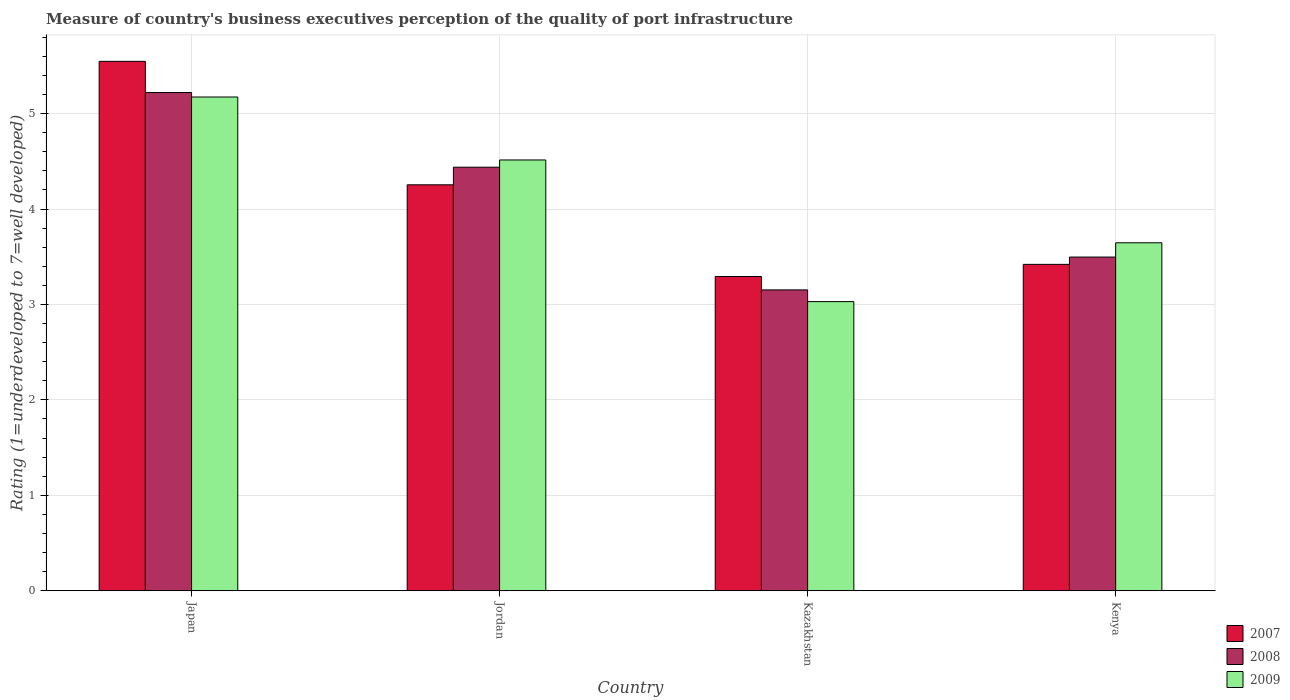How many different coloured bars are there?
Ensure brevity in your answer.  3. Are the number of bars per tick equal to the number of legend labels?
Offer a very short reply. Yes. Are the number of bars on each tick of the X-axis equal?
Your answer should be compact. Yes. How many bars are there on the 3rd tick from the left?
Your answer should be very brief. 3. What is the label of the 3rd group of bars from the left?
Offer a very short reply. Kazakhstan. In how many cases, is the number of bars for a given country not equal to the number of legend labels?
Your answer should be compact. 0. What is the ratings of the quality of port infrastructure in 2009 in Kazakhstan?
Your answer should be very brief. 3.03. Across all countries, what is the maximum ratings of the quality of port infrastructure in 2009?
Provide a succinct answer. 5.17. Across all countries, what is the minimum ratings of the quality of port infrastructure in 2008?
Give a very brief answer. 3.15. In which country was the ratings of the quality of port infrastructure in 2007 minimum?
Make the answer very short. Kazakhstan. What is the total ratings of the quality of port infrastructure in 2009 in the graph?
Offer a terse response. 16.36. What is the difference between the ratings of the quality of port infrastructure in 2007 in Japan and that in Kenya?
Your answer should be compact. 2.13. What is the difference between the ratings of the quality of port infrastructure in 2008 in Kazakhstan and the ratings of the quality of port infrastructure in 2009 in Kenya?
Make the answer very short. -0.49. What is the average ratings of the quality of port infrastructure in 2009 per country?
Your response must be concise. 4.09. What is the difference between the ratings of the quality of port infrastructure of/in 2008 and ratings of the quality of port infrastructure of/in 2009 in Kenya?
Make the answer very short. -0.15. What is the ratio of the ratings of the quality of port infrastructure in 2008 in Jordan to that in Kenya?
Your answer should be very brief. 1.27. Is the ratings of the quality of port infrastructure in 2009 in Japan less than that in Kazakhstan?
Your answer should be very brief. No. What is the difference between the highest and the second highest ratings of the quality of port infrastructure in 2007?
Your response must be concise. -0.83. What is the difference between the highest and the lowest ratings of the quality of port infrastructure in 2009?
Your answer should be very brief. 2.14. In how many countries, is the ratings of the quality of port infrastructure in 2008 greater than the average ratings of the quality of port infrastructure in 2008 taken over all countries?
Offer a very short reply. 2. What does the 1st bar from the left in Japan represents?
Make the answer very short. 2007. What does the 1st bar from the right in Kazakhstan represents?
Ensure brevity in your answer.  2009. Is it the case that in every country, the sum of the ratings of the quality of port infrastructure in 2007 and ratings of the quality of port infrastructure in 2008 is greater than the ratings of the quality of port infrastructure in 2009?
Give a very brief answer. Yes. How many countries are there in the graph?
Your answer should be very brief. 4. What is the difference between two consecutive major ticks on the Y-axis?
Your answer should be compact. 1. Does the graph contain any zero values?
Your response must be concise. No. Where does the legend appear in the graph?
Offer a terse response. Bottom right. How are the legend labels stacked?
Ensure brevity in your answer.  Vertical. What is the title of the graph?
Provide a succinct answer. Measure of country's business executives perception of the quality of port infrastructure. What is the label or title of the X-axis?
Provide a short and direct response. Country. What is the label or title of the Y-axis?
Provide a succinct answer. Rating (1=underdeveloped to 7=well developed). What is the Rating (1=underdeveloped to 7=well developed) of 2007 in Japan?
Offer a very short reply. 5.55. What is the Rating (1=underdeveloped to 7=well developed) of 2008 in Japan?
Your answer should be very brief. 5.22. What is the Rating (1=underdeveloped to 7=well developed) in 2009 in Japan?
Your answer should be very brief. 5.17. What is the Rating (1=underdeveloped to 7=well developed) of 2007 in Jordan?
Give a very brief answer. 4.25. What is the Rating (1=underdeveloped to 7=well developed) in 2008 in Jordan?
Your response must be concise. 4.44. What is the Rating (1=underdeveloped to 7=well developed) in 2009 in Jordan?
Give a very brief answer. 4.51. What is the Rating (1=underdeveloped to 7=well developed) of 2007 in Kazakhstan?
Offer a very short reply. 3.29. What is the Rating (1=underdeveloped to 7=well developed) of 2008 in Kazakhstan?
Your answer should be compact. 3.15. What is the Rating (1=underdeveloped to 7=well developed) in 2009 in Kazakhstan?
Provide a short and direct response. 3.03. What is the Rating (1=underdeveloped to 7=well developed) in 2007 in Kenya?
Your answer should be very brief. 3.42. What is the Rating (1=underdeveloped to 7=well developed) in 2008 in Kenya?
Your answer should be compact. 3.5. What is the Rating (1=underdeveloped to 7=well developed) in 2009 in Kenya?
Give a very brief answer. 3.65. Across all countries, what is the maximum Rating (1=underdeveloped to 7=well developed) in 2007?
Your response must be concise. 5.55. Across all countries, what is the maximum Rating (1=underdeveloped to 7=well developed) of 2008?
Make the answer very short. 5.22. Across all countries, what is the maximum Rating (1=underdeveloped to 7=well developed) in 2009?
Keep it short and to the point. 5.17. Across all countries, what is the minimum Rating (1=underdeveloped to 7=well developed) in 2007?
Offer a very short reply. 3.29. Across all countries, what is the minimum Rating (1=underdeveloped to 7=well developed) of 2008?
Your response must be concise. 3.15. Across all countries, what is the minimum Rating (1=underdeveloped to 7=well developed) in 2009?
Give a very brief answer. 3.03. What is the total Rating (1=underdeveloped to 7=well developed) in 2007 in the graph?
Make the answer very short. 16.51. What is the total Rating (1=underdeveloped to 7=well developed) of 2008 in the graph?
Give a very brief answer. 16.31. What is the total Rating (1=underdeveloped to 7=well developed) of 2009 in the graph?
Ensure brevity in your answer.  16.36. What is the difference between the Rating (1=underdeveloped to 7=well developed) in 2007 in Japan and that in Jordan?
Offer a very short reply. 1.29. What is the difference between the Rating (1=underdeveloped to 7=well developed) of 2008 in Japan and that in Jordan?
Provide a short and direct response. 0.78. What is the difference between the Rating (1=underdeveloped to 7=well developed) of 2009 in Japan and that in Jordan?
Make the answer very short. 0.66. What is the difference between the Rating (1=underdeveloped to 7=well developed) in 2007 in Japan and that in Kazakhstan?
Provide a short and direct response. 2.25. What is the difference between the Rating (1=underdeveloped to 7=well developed) of 2008 in Japan and that in Kazakhstan?
Provide a succinct answer. 2.07. What is the difference between the Rating (1=underdeveloped to 7=well developed) in 2009 in Japan and that in Kazakhstan?
Your answer should be compact. 2.14. What is the difference between the Rating (1=underdeveloped to 7=well developed) in 2007 in Japan and that in Kenya?
Your answer should be very brief. 2.13. What is the difference between the Rating (1=underdeveloped to 7=well developed) in 2008 in Japan and that in Kenya?
Your answer should be very brief. 1.72. What is the difference between the Rating (1=underdeveloped to 7=well developed) of 2009 in Japan and that in Kenya?
Your response must be concise. 1.53. What is the difference between the Rating (1=underdeveloped to 7=well developed) in 2007 in Jordan and that in Kazakhstan?
Make the answer very short. 0.96. What is the difference between the Rating (1=underdeveloped to 7=well developed) of 2008 in Jordan and that in Kazakhstan?
Your answer should be very brief. 1.29. What is the difference between the Rating (1=underdeveloped to 7=well developed) of 2009 in Jordan and that in Kazakhstan?
Your answer should be very brief. 1.48. What is the difference between the Rating (1=underdeveloped to 7=well developed) in 2007 in Jordan and that in Kenya?
Provide a succinct answer. 0.83. What is the difference between the Rating (1=underdeveloped to 7=well developed) of 2008 in Jordan and that in Kenya?
Offer a very short reply. 0.94. What is the difference between the Rating (1=underdeveloped to 7=well developed) in 2009 in Jordan and that in Kenya?
Provide a short and direct response. 0.87. What is the difference between the Rating (1=underdeveloped to 7=well developed) of 2007 in Kazakhstan and that in Kenya?
Your answer should be very brief. -0.13. What is the difference between the Rating (1=underdeveloped to 7=well developed) of 2008 in Kazakhstan and that in Kenya?
Your answer should be very brief. -0.34. What is the difference between the Rating (1=underdeveloped to 7=well developed) of 2009 in Kazakhstan and that in Kenya?
Offer a terse response. -0.62. What is the difference between the Rating (1=underdeveloped to 7=well developed) of 2007 in Japan and the Rating (1=underdeveloped to 7=well developed) of 2008 in Jordan?
Your answer should be very brief. 1.11. What is the difference between the Rating (1=underdeveloped to 7=well developed) in 2007 in Japan and the Rating (1=underdeveloped to 7=well developed) in 2009 in Jordan?
Provide a succinct answer. 1.03. What is the difference between the Rating (1=underdeveloped to 7=well developed) in 2008 in Japan and the Rating (1=underdeveloped to 7=well developed) in 2009 in Jordan?
Ensure brevity in your answer.  0.71. What is the difference between the Rating (1=underdeveloped to 7=well developed) in 2007 in Japan and the Rating (1=underdeveloped to 7=well developed) in 2008 in Kazakhstan?
Your response must be concise. 2.4. What is the difference between the Rating (1=underdeveloped to 7=well developed) in 2007 in Japan and the Rating (1=underdeveloped to 7=well developed) in 2009 in Kazakhstan?
Offer a terse response. 2.52. What is the difference between the Rating (1=underdeveloped to 7=well developed) in 2008 in Japan and the Rating (1=underdeveloped to 7=well developed) in 2009 in Kazakhstan?
Provide a short and direct response. 2.19. What is the difference between the Rating (1=underdeveloped to 7=well developed) in 2007 in Japan and the Rating (1=underdeveloped to 7=well developed) in 2008 in Kenya?
Provide a short and direct response. 2.05. What is the difference between the Rating (1=underdeveloped to 7=well developed) in 2007 in Japan and the Rating (1=underdeveloped to 7=well developed) in 2009 in Kenya?
Offer a very short reply. 1.9. What is the difference between the Rating (1=underdeveloped to 7=well developed) in 2008 in Japan and the Rating (1=underdeveloped to 7=well developed) in 2009 in Kenya?
Offer a very short reply. 1.57. What is the difference between the Rating (1=underdeveloped to 7=well developed) in 2007 in Jordan and the Rating (1=underdeveloped to 7=well developed) in 2008 in Kazakhstan?
Your answer should be very brief. 1.1. What is the difference between the Rating (1=underdeveloped to 7=well developed) in 2007 in Jordan and the Rating (1=underdeveloped to 7=well developed) in 2009 in Kazakhstan?
Give a very brief answer. 1.22. What is the difference between the Rating (1=underdeveloped to 7=well developed) in 2008 in Jordan and the Rating (1=underdeveloped to 7=well developed) in 2009 in Kazakhstan?
Provide a succinct answer. 1.41. What is the difference between the Rating (1=underdeveloped to 7=well developed) in 2007 in Jordan and the Rating (1=underdeveloped to 7=well developed) in 2008 in Kenya?
Offer a very short reply. 0.76. What is the difference between the Rating (1=underdeveloped to 7=well developed) of 2007 in Jordan and the Rating (1=underdeveloped to 7=well developed) of 2009 in Kenya?
Ensure brevity in your answer.  0.61. What is the difference between the Rating (1=underdeveloped to 7=well developed) in 2008 in Jordan and the Rating (1=underdeveloped to 7=well developed) in 2009 in Kenya?
Your answer should be very brief. 0.79. What is the difference between the Rating (1=underdeveloped to 7=well developed) of 2007 in Kazakhstan and the Rating (1=underdeveloped to 7=well developed) of 2008 in Kenya?
Offer a very short reply. -0.2. What is the difference between the Rating (1=underdeveloped to 7=well developed) in 2007 in Kazakhstan and the Rating (1=underdeveloped to 7=well developed) in 2009 in Kenya?
Your answer should be compact. -0.35. What is the difference between the Rating (1=underdeveloped to 7=well developed) of 2008 in Kazakhstan and the Rating (1=underdeveloped to 7=well developed) of 2009 in Kenya?
Make the answer very short. -0.49. What is the average Rating (1=underdeveloped to 7=well developed) in 2007 per country?
Keep it short and to the point. 4.13. What is the average Rating (1=underdeveloped to 7=well developed) in 2008 per country?
Provide a succinct answer. 4.08. What is the average Rating (1=underdeveloped to 7=well developed) in 2009 per country?
Offer a very short reply. 4.09. What is the difference between the Rating (1=underdeveloped to 7=well developed) in 2007 and Rating (1=underdeveloped to 7=well developed) in 2008 in Japan?
Make the answer very short. 0.33. What is the difference between the Rating (1=underdeveloped to 7=well developed) of 2007 and Rating (1=underdeveloped to 7=well developed) of 2009 in Japan?
Offer a terse response. 0.37. What is the difference between the Rating (1=underdeveloped to 7=well developed) of 2008 and Rating (1=underdeveloped to 7=well developed) of 2009 in Japan?
Offer a very short reply. 0.05. What is the difference between the Rating (1=underdeveloped to 7=well developed) of 2007 and Rating (1=underdeveloped to 7=well developed) of 2008 in Jordan?
Keep it short and to the point. -0.18. What is the difference between the Rating (1=underdeveloped to 7=well developed) in 2007 and Rating (1=underdeveloped to 7=well developed) in 2009 in Jordan?
Provide a short and direct response. -0.26. What is the difference between the Rating (1=underdeveloped to 7=well developed) of 2008 and Rating (1=underdeveloped to 7=well developed) of 2009 in Jordan?
Your response must be concise. -0.08. What is the difference between the Rating (1=underdeveloped to 7=well developed) in 2007 and Rating (1=underdeveloped to 7=well developed) in 2008 in Kazakhstan?
Offer a terse response. 0.14. What is the difference between the Rating (1=underdeveloped to 7=well developed) in 2007 and Rating (1=underdeveloped to 7=well developed) in 2009 in Kazakhstan?
Provide a short and direct response. 0.26. What is the difference between the Rating (1=underdeveloped to 7=well developed) of 2008 and Rating (1=underdeveloped to 7=well developed) of 2009 in Kazakhstan?
Your answer should be very brief. 0.12. What is the difference between the Rating (1=underdeveloped to 7=well developed) in 2007 and Rating (1=underdeveloped to 7=well developed) in 2008 in Kenya?
Ensure brevity in your answer.  -0.08. What is the difference between the Rating (1=underdeveloped to 7=well developed) of 2007 and Rating (1=underdeveloped to 7=well developed) of 2009 in Kenya?
Provide a succinct answer. -0.23. What is the difference between the Rating (1=underdeveloped to 7=well developed) in 2008 and Rating (1=underdeveloped to 7=well developed) in 2009 in Kenya?
Your answer should be very brief. -0.15. What is the ratio of the Rating (1=underdeveloped to 7=well developed) of 2007 in Japan to that in Jordan?
Your response must be concise. 1.3. What is the ratio of the Rating (1=underdeveloped to 7=well developed) of 2008 in Japan to that in Jordan?
Give a very brief answer. 1.18. What is the ratio of the Rating (1=underdeveloped to 7=well developed) in 2009 in Japan to that in Jordan?
Your response must be concise. 1.15. What is the ratio of the Rating (1=underdeveloped to 7=well developed) of 2007 in Japan to that in Kazakhstan?
Keep it short and to the point. 1.68. What is the ratio of the Rating (1=underdeveloped to 7=well developed) in 2008 in Japan to that in Kazakhstan?
Your answer should be compact. 1.66. What is the ratio of the Rating (1=underdeveloped to 7=well developed) of 2009 in Japan to that in Kazakhstan?
Offer a terse response. 1.71. What is the ratio of the Rating (1=underdeveloped to 7=well developed) of 2007 in Japan to that in Kenya?
Provide a short and direct response. 1.62. What is the ratio of the Rating (1=underdeveloped to 7=well developed) in 2008 in Japan to that in Kenya?
Give a very brief answer. 1.49. What is the ratio of the Rating (1=underdeveloped to 7=well developed) in 2009 in Japan to that in Kenya?
Provide a succinct answer. 1.42. What is the ratio of the Rating (1=underdeveloped to 7=well developed) of 2007 in Jordan to that in Kazakhstan?
Offer a very short reply. 1.29. What is the ratio of the Rating (1=underdeveloped to 7=well developed) in 2008 in Jordan to that in Kazakhstan?
Your answer should be compact. 1.41. What is the ratio of the Rating (1=underdeveloped to 7=well developed) of 2009 in Jordan to that in Kazakhstan?
Provide a succinct answer. 1.49. What is the ratio of the Rating (1=underdeveloped to 7=well developed) in 2007 in Jordan to that in Kenya?
Offer a terse response. 1.24. What is the ratio of the Rating (1=underdeveloped to 7=well developed) of 2008 in Jordan to that in Kenya?
Your answer should be very brief. 1.27. What is the ratio of the Rating (1=underdeveloped to 7=well developed) of 2009 in Jordan to that in Kenya?
Ensure brevity in your answer.  1.24. What is the ratio of the Rating (1=underdeveloped to 7=well developed) of 2007 in Kazakhstan to that in Kenya?
Ensure brevity in your answer.  0.96. What is the ratio of the Rating (1=underdeveloped to 7=well developed) of 2008 in Kazakhstan to that in Kenya?
Offer a terse response. 0.9. What is the ratio of the Rating (1=underdeveloped to 7=well developed) of 2009 in Kazakhstan to that in Kenya?
Provide a short and direct response. 0.83. What is the difference between the highest and the second highest Rating (1=underdeveloped to 7=well developed) of 2007?
Provide a short and direct response. 1.29. What is the difference between the highest and the second highest Rating (1=underdeveloped to 7=well developed) in 2008?
Provide a short and direct response. 0.78. What is the difference between the highest and the second highest Rating (1=underdeveloped to 7=well developed) of 2009?
Provide a short and direct response. 0.66. What is the difference between the highest and the lowest Rating (1=underdeveloped to 7=well developed) of 2007?
Ensure brevity in your answer.  2.25. What is the difference between the highest and the lowest Rating (1=underdeveloped to 7=well developed) of 2008?
Your answer should be very brief. 2.07. What is the difference between the highest and the lowest Rating (1=underdeveloped to 7=well developed) in 2009?
Your answer should be very brief. 2.14. 